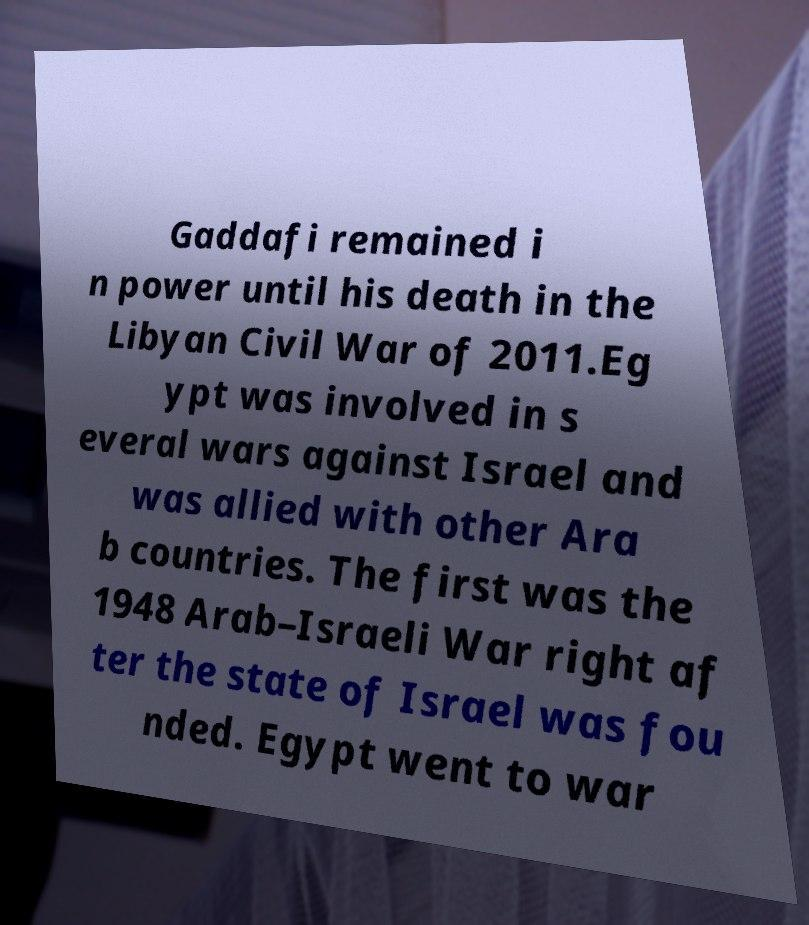There's text embedded in this image that I need extracted. Can you transcribe it verbatim? Gaddafi remained i n power until his death in the Libyan Civil War of 2011.Eg ypt was involved in s everal wars against Israel and was allied with other Ara b countries. The first was the 1948 Arab–Israeli War right af ter the state of Israel was fou nded. Egypt went to war 